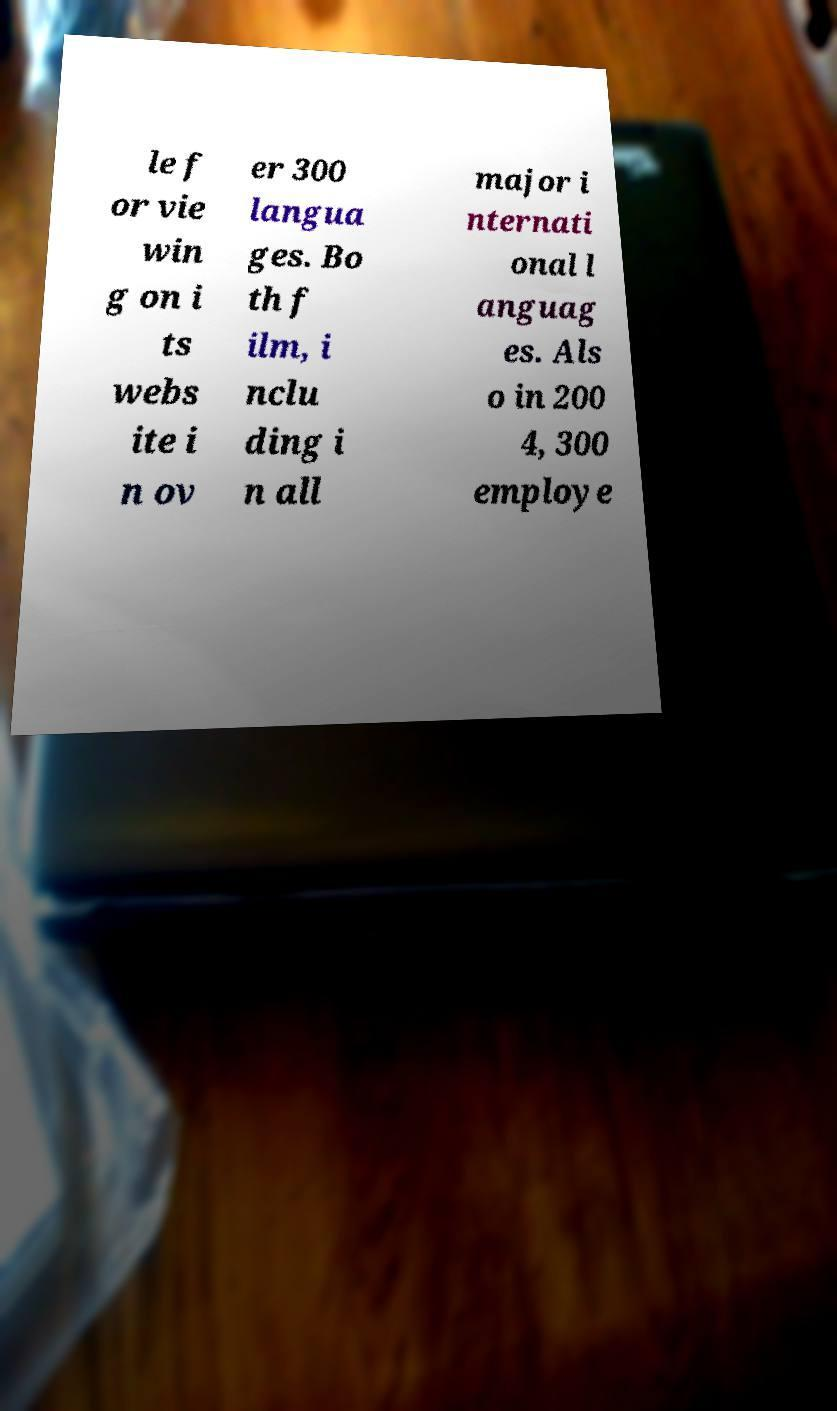I need the written content from this picture converted into text. Can you do that? le f or vie win g on i ts webs ite i n ov er 300 langua ges. Bo th f ilm, i nclu ding i n all major i nternati onal l anguag es. Als o in 200 4, 300 employe 